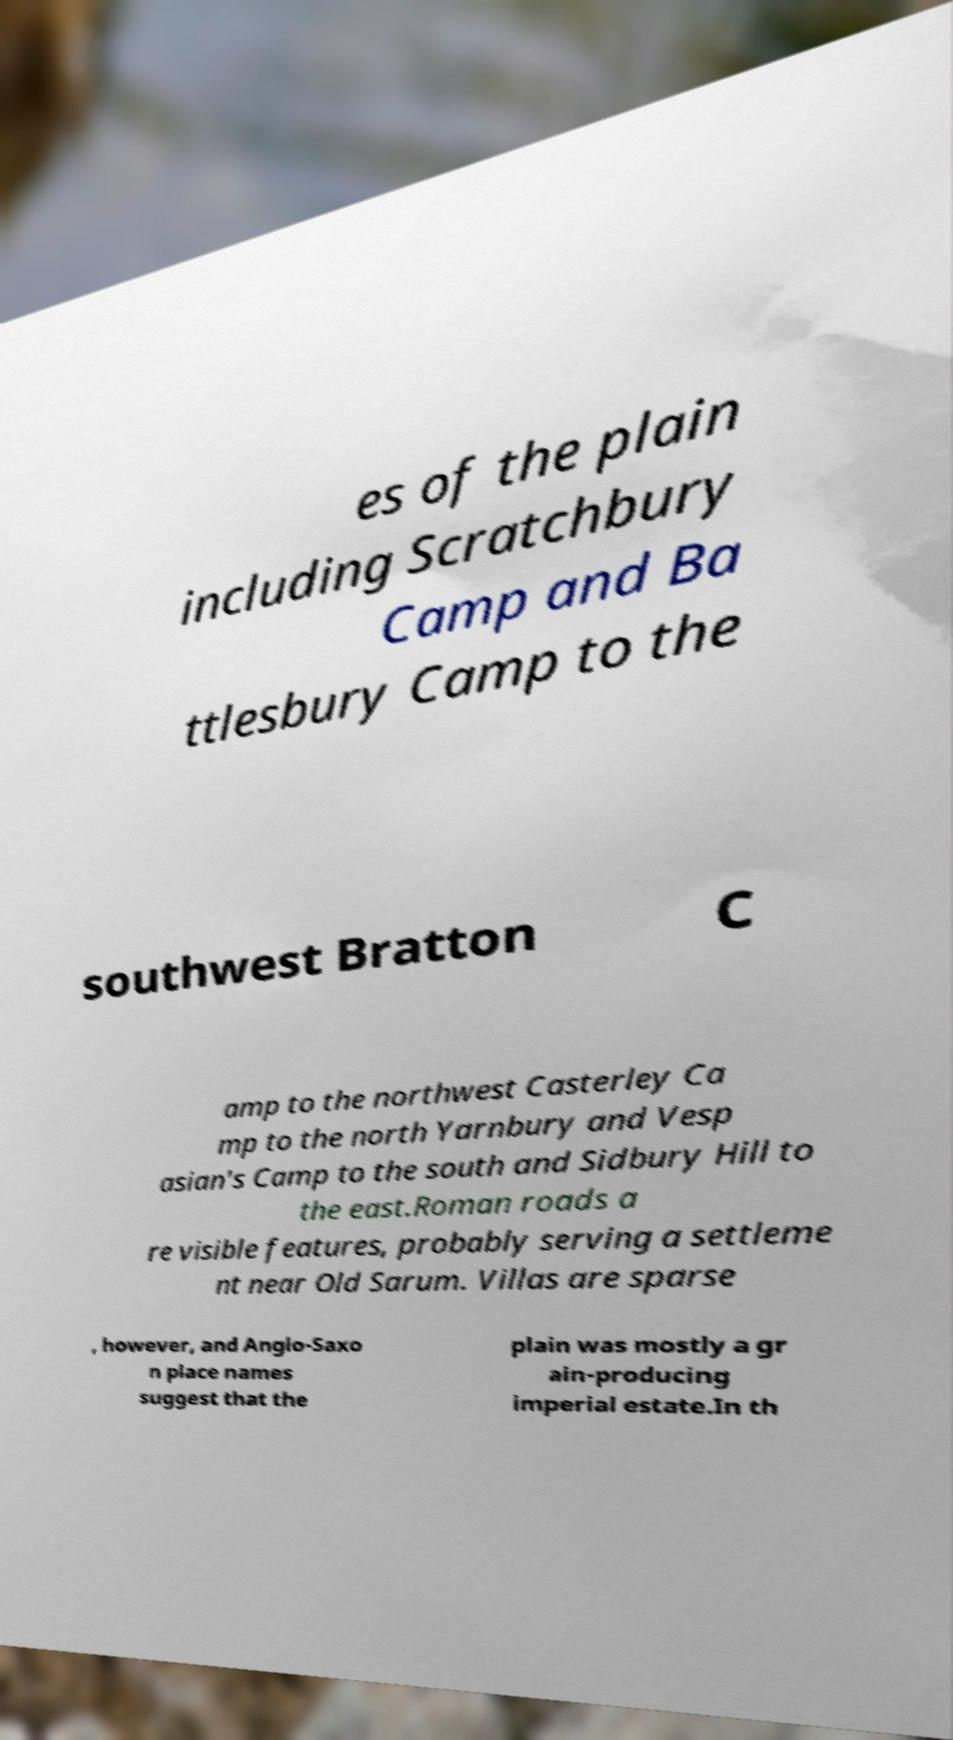Could you assist in decoding the text presented in this image and type it out clearly? es of the plain including Scratchbury Camp and Ba ttlesbury Camp to the southwest Bratton C amp to the northwest Casterley Ca mp to the north Yarnbury and Vesp asian's Camp to the south and Sidbury Hill to the east.Roman roads a re visible features, probably serving a settleme nt near Old Sarum. Villas are sparse , however, and Anglo-Saxo n place names suggest that the plain was mostly a gr ain-producing imperial estate.In th 